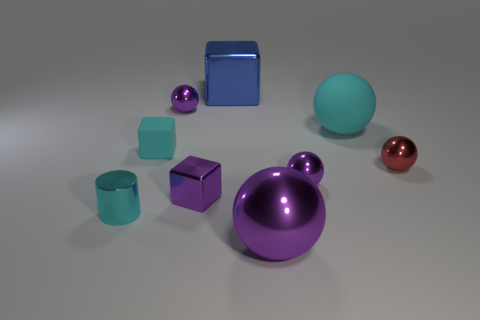Subtract all purple balls. How many were subtracted if there are1purple balls left? 2 Subtract all purple cylinders. How many purple balls are left? 3 Subtract all tiny cubes. How many cubes are left? 1 Subtract all red spheres. How many spheres are left? 4 Subtract 3 spheres. How many spheres are left? 2 Subtract all cylinders. How many objects are left? 8 Subtract all large metallic things. Subtract all large balls. How many objects are left? 5 Add 6 large blue metal objects. How many large blue metal objects are left? 7 Add 3 cyan matte things. How many cyan matte things exist? 5 Subtract 1 purple cubes. How many objects are left? 8 